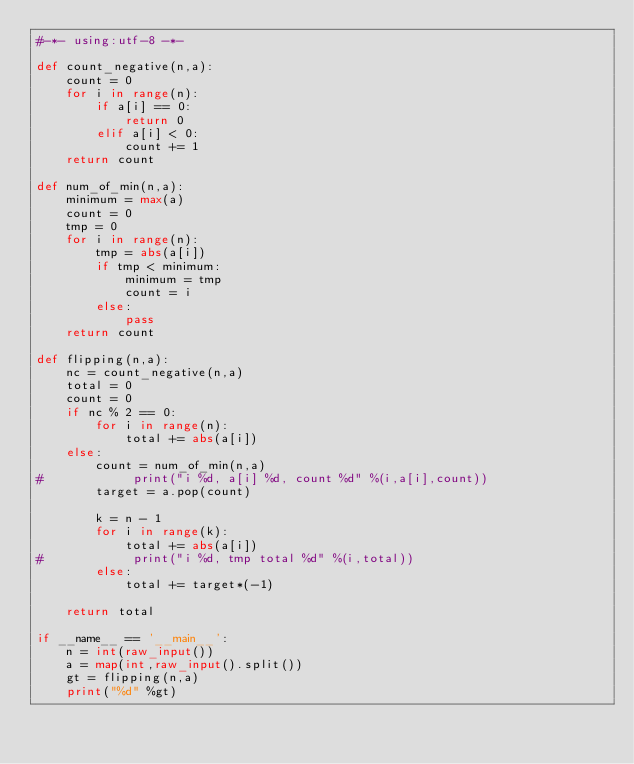<code> <loc_0><loc_0><loc_500><loc_500><_Python_>#-*- using:utf-8 -*-

def count_negative(n,a):
    count = 0
    for i in range(n):
        if a[i] == 0:
            return 0
        elif a[i] < 0:
            count += 1
    return count

def num_of_min(n,a):
    minimum = max(a)
    count = 0    
    tmp = 0
    for i in range(n):
        tmp = abs(a[i])
        if tmp < minimum:
            minimum = tmp
            count = i
        else:
            pass
    return count

def flipping(n,a):
    nc = count_negative(n,a)
    total = 0
    count = 0
    if nc % 2 == 0:
        for i in range(n):
            total += abs(a[i])
    else:
        count = num_of_min(n,a)
#            print("i %d, a[i] %d, count %d" %(i,a[i],count))
        target = a.pop(count)

        k = n - 1
        for i in range(k):
            total += abs(a[i])
#            print("i %d, tmp total %d" %(i,total))
        else:
            total += target*(-1)

    return total

if __name__ == '__main__':
    n = int(raw_input())
    a = map(int,raw_input().split())
    gt = flipping(n,a)
    print("%d" %gt)
</code> 